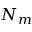<formula> <loc_0><loc_0><loc_500><loc_500>N _ { m }</formula> 